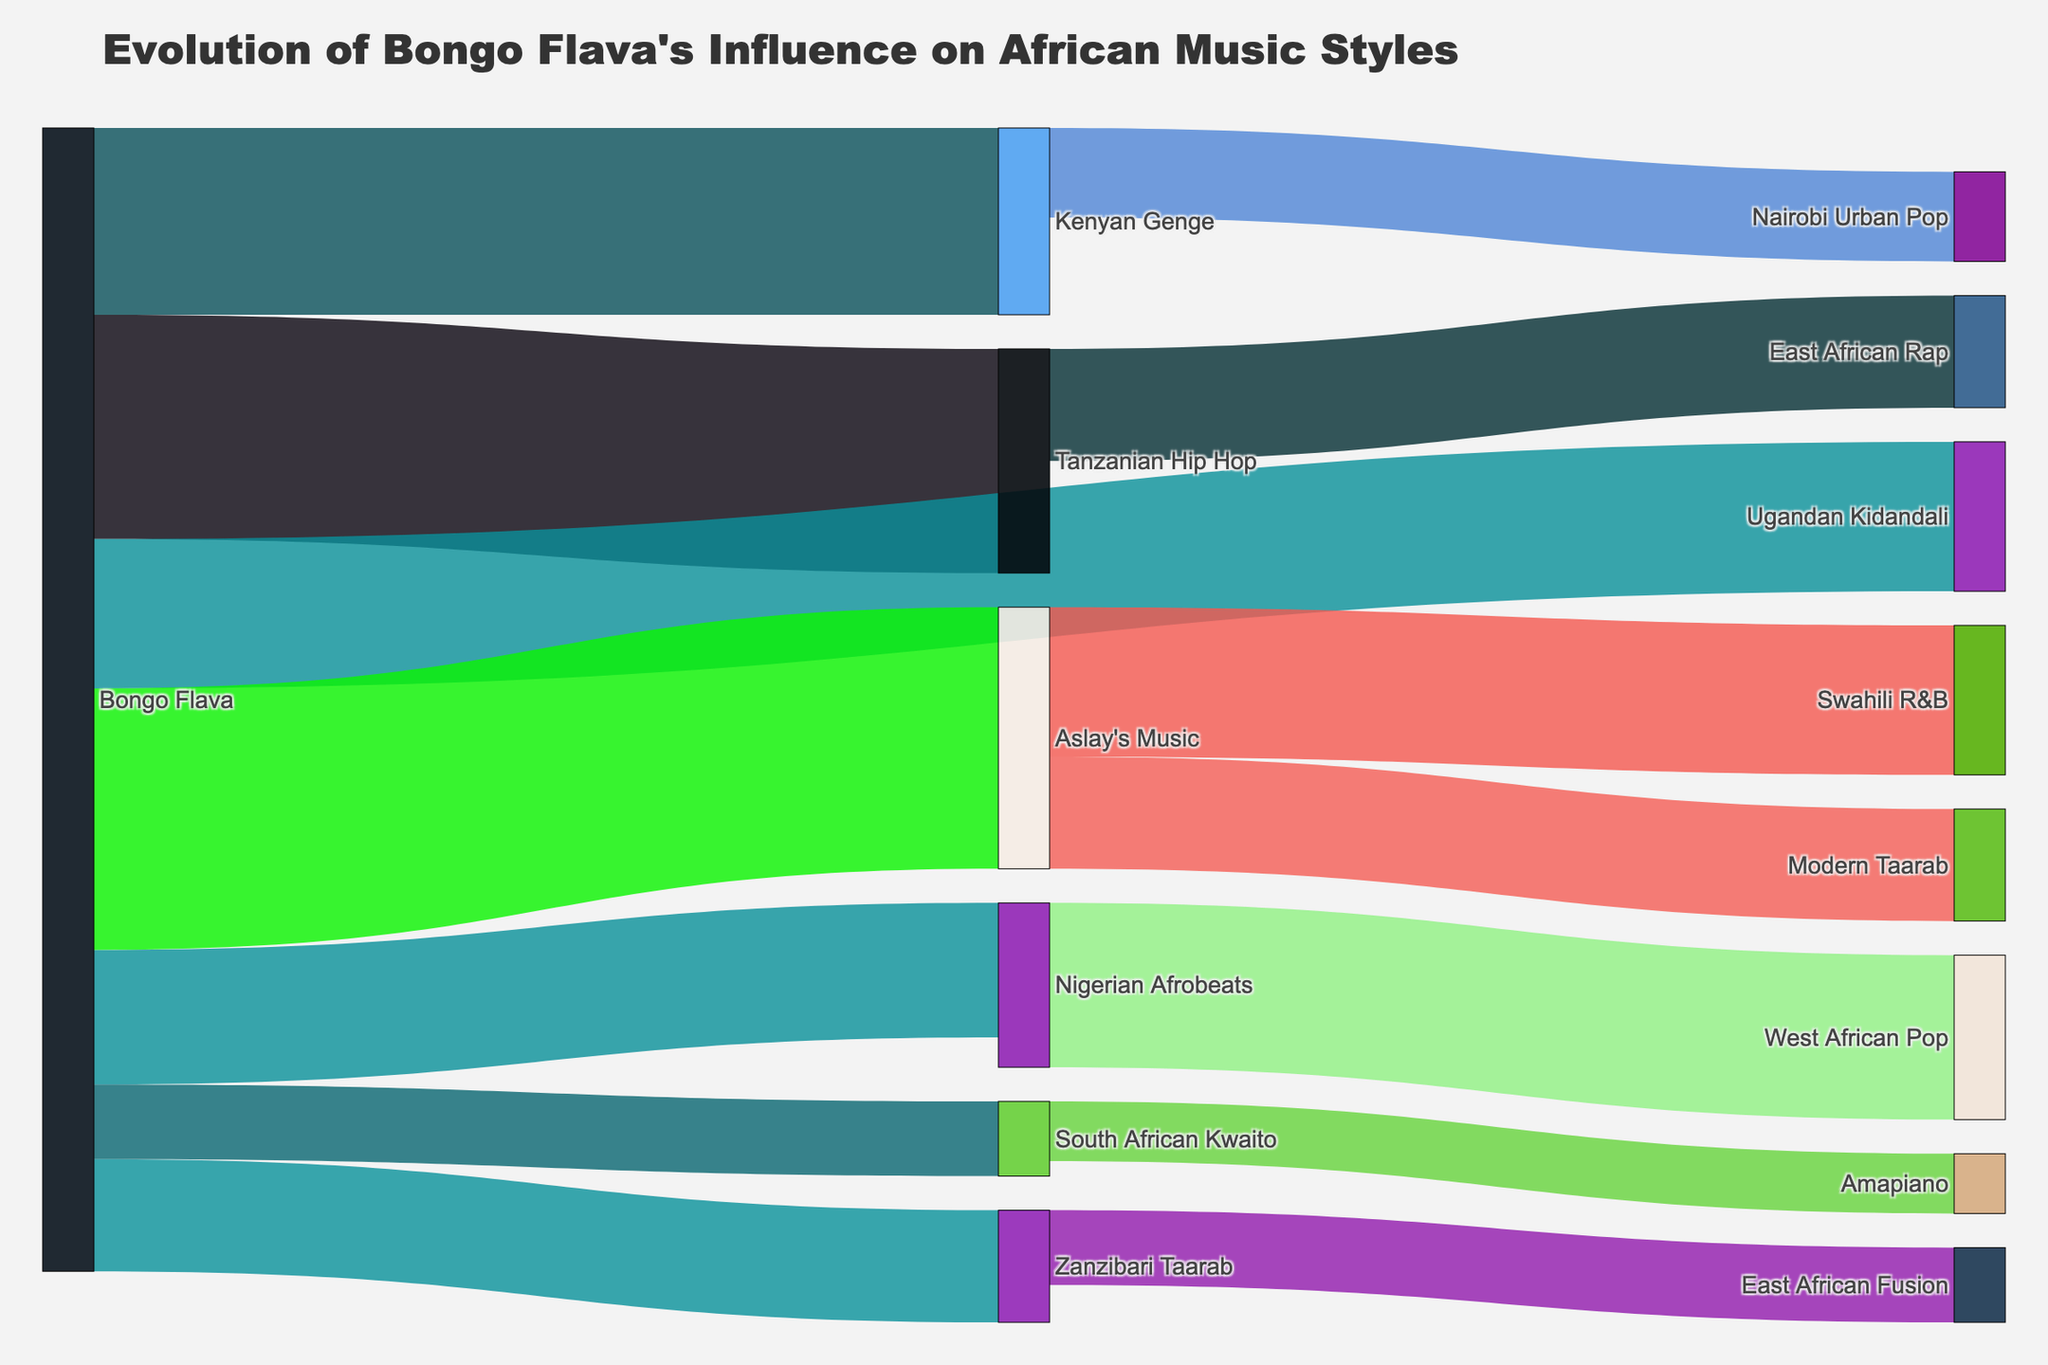How many connections does Bongo Flava have to other music styles? Bongo Flava has connections to Tanzanian Hip Hop, Kenyan Genge, Ugandan Kidandali, Nigerian Afrobeats, South African Kwaito, Aslay's Music, and Zanzibari Taarab. That's a total of 7 connections.
Answer: 7 What is the most significant influence among the targets directly influenced by Bongo Flava? The figure shows the values of the connections originating from Bongo Flava. The connection with the highest value is between Bongo Flava and Aslay's Music, with a value of 35.
Answer: Aslay's Music Which music style does Aslay's Music influence the most? Aslay's Music influences Modern Taarab and Swahili R&B. The connection with the highest value among these is Swahili R&B with a value of 20.
Answer: Swahili R&B Sum the values of all influences originating from Bongo Flava. Adding the values of all the connections that Bongo Flava influences: 30 (to Tanzanian Hip Hop) + 25 (to Kenyan Genge) + 20 (to Ugandan Kidandali) + 18 (to Nigerian Afrobeats) + 10 (to South African Kwaito) + 35 (to Aslay's Music) + 15 (to Zanzibari Taarab) = 153.
Answer: 153 Which connection has the smallest value, and what is its value? The figure shows the values of different connections between music styles. The smallest value is the connection from South African Kwaito to Amapiano, with a value of 8.
Answer: Amapiano from South African Kwaito, 8 What is the combined influence on East African music styles (Tanzanian Hip Hop, Kenyan Genge, Ugandan Kidandali)? Adding the values of the connections from Bongo Flava to Tanzanian Hip Hop (30), Kenyan Genge (25), and Ugandan Kidandali (20): 30 + 25 + 20 = 75.
Answer: 75 Compare the influence of Bongo Flava on Nigerian Afrobeats and South African Kwaito. Which one is stronger and by how much? The figure shows that Bongo Flava influences Nigerian Afrobeats with a value of 18 and South African Kwaito with a value of 10. The influence on Nigerian Afrobeats is stronger by 18 - 10 = 8.
Answer: Nigerian Afrobeats, by 8 What is the total value of influences that Aslay's Music and Zanzibari Taarab have on other styles? Aslay's Music influences Modern Taarab (15) and Swahili R&B (20). Zanzibari Taarab influences East African Fusion (10). Summing these: 15 + 20 + 10 = 45.
Answer: 45 Which music style has a direct influence on Amapiano and what is the value? The figure shows that Amapiano is influenced directly by South African Kwaito with a value of 8.
Answer: South African Kwaito, 8 Which music style gets influenced the most by Bongo Flava, other than Aslay's Music, based on the figure? Other than Aslay's Music (35), the highest influence by Bongo Flava is on Tanzanian Hip Hop with a value of 30.
Answer: Tanzanian Hip Hop 